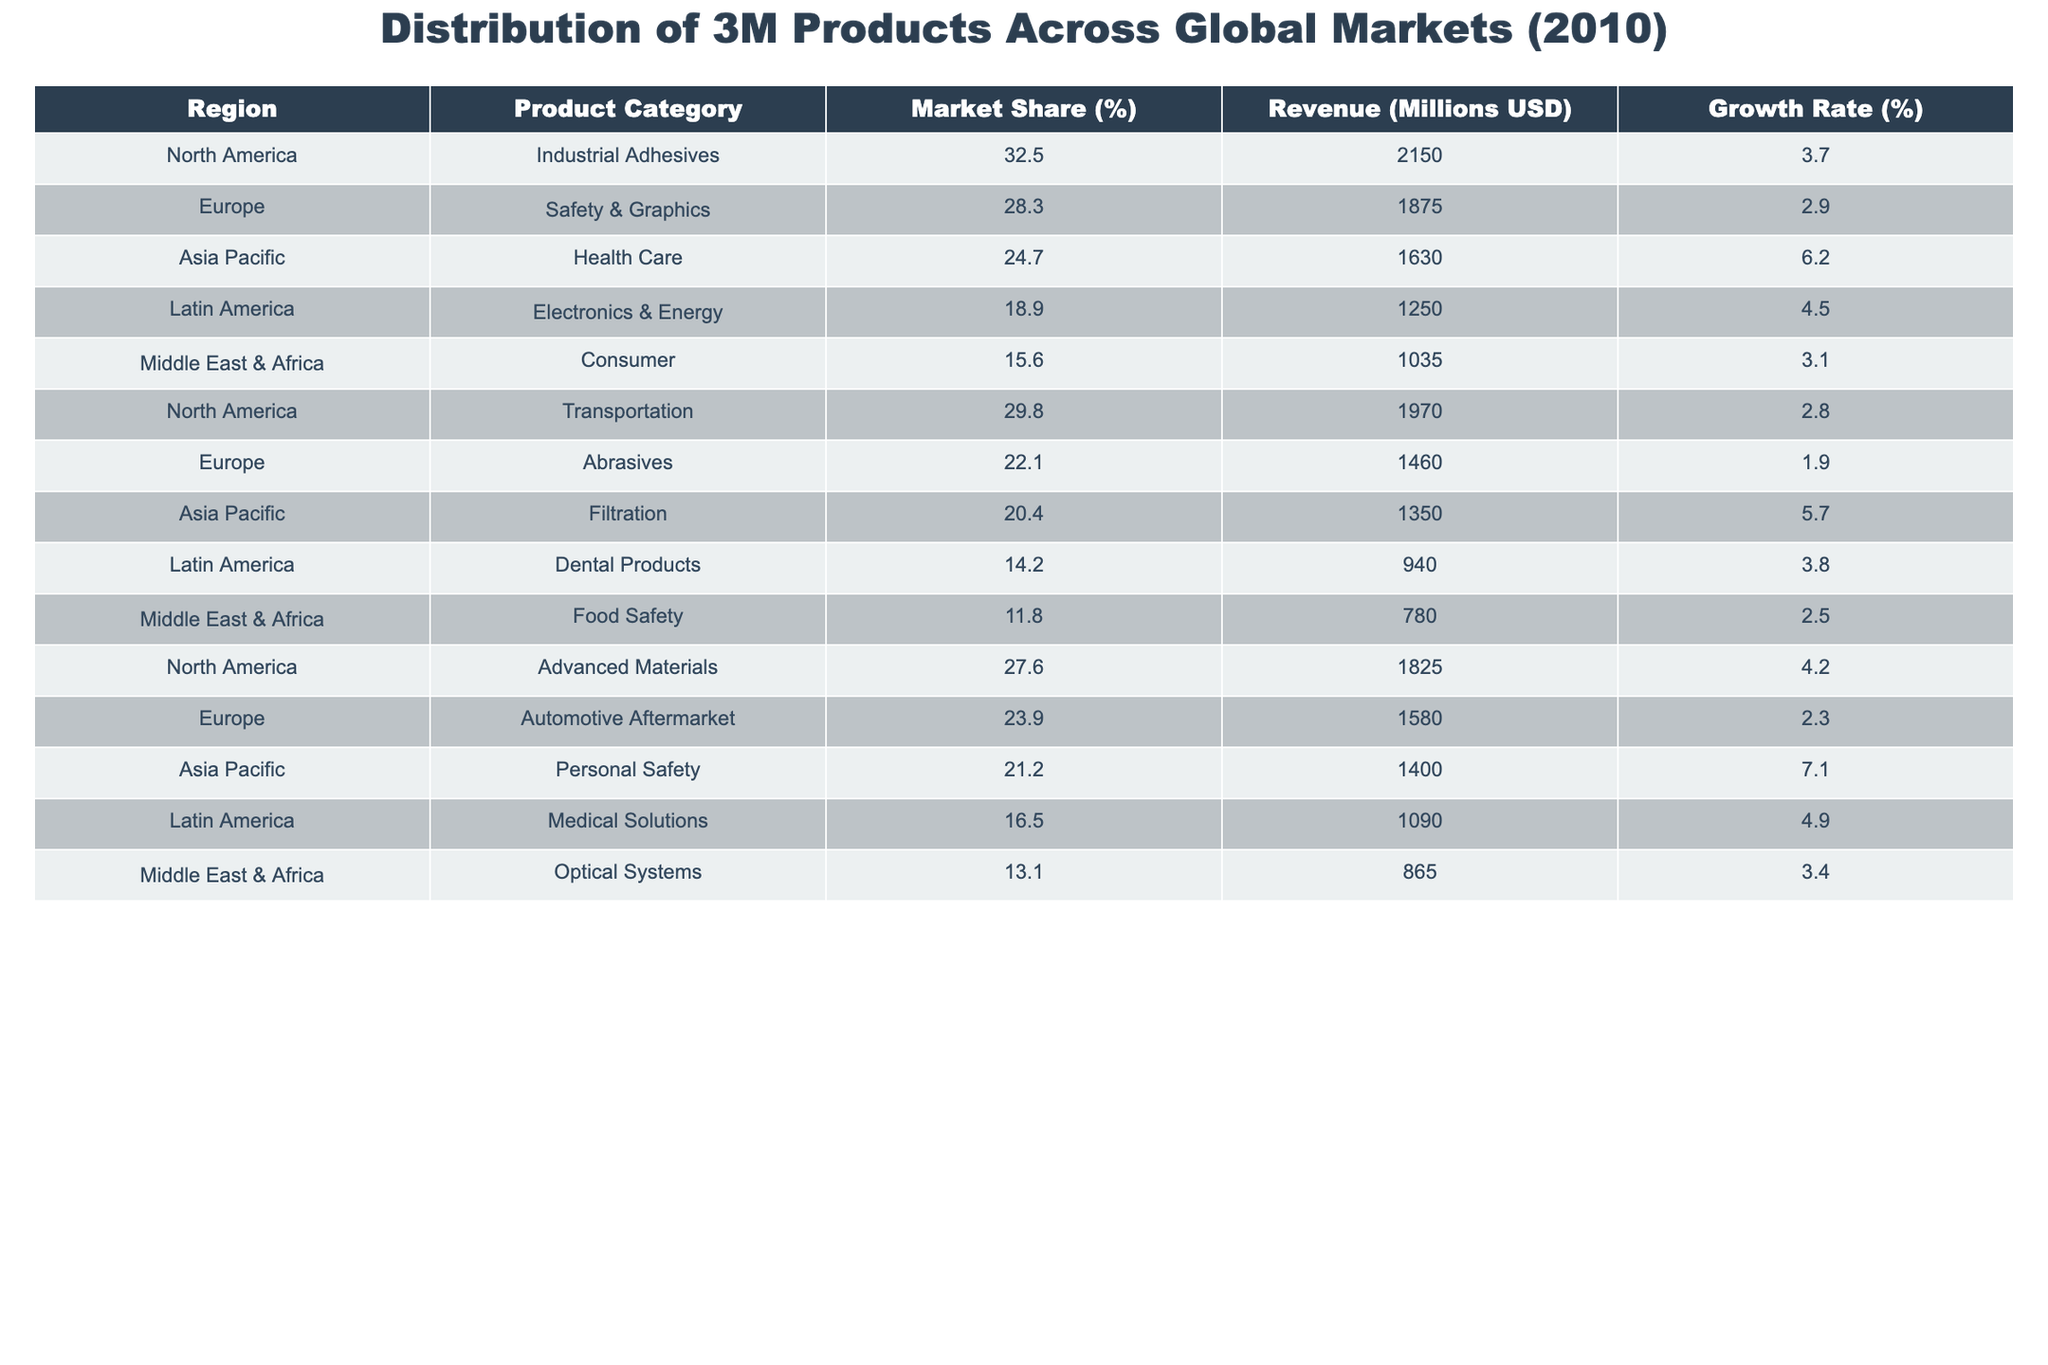What is the market share of Industrial Adhesives in North America? The table shows that Industrial Adhesives has a market share of 32.5% in North America.
Answer: 32.5% Which product category generates the highest revenue in Europe? In the table, Safety & Graphics has the highest revenue of 1875 million USD in Europe.
Answer: Safety & Graphics What is the growth rate of Personal Safety in Asia Pacific? The table lists Personal Safety with a growth rate of 7.1% in the Asia Pacific region.
Answer: 7.1% How does the market share of Consumer products in the Middle East & Africa compare to that of Food Safety? The market share of Consumer is 15.6% while Food Safety is 11.8%, which indicates that Consumer has a higher market share by 3.8%.
Answer: Yes, Consumer has a higher market share What is the total revenue generated by 3M products in Latin America? Adding the revenues of Electronics & Energy (1250 million USD), Dental Products (940 million USD), and Medical Solutions (1090 million USD), the total revenue is 1250 + 940 + 1090 = 3280 million USD.
Answer: 3280 million USD Which region has the lowest growth rate among the listed product categories? The lowest growth rate listed is 1.9% for Abrasives in Europe.
Answer: Abrasives in Europe What is the average market share of the product categories in North America? The market shares in North America are 32.5%, 29.8%, and 27.6%. Summing them gives 32.5 + 29.8 + 27.6 = 89.9; dividing by 3 gives an average of 29.97%.
Answer: 29.97% How many product categories in Asia Pacific have a growth rate above 6%? The table shows two product categories with growth rates above 6%: Health Care (6.2%) and Personal Safety (7.1%).
Answer: 2 What is the difference in market share between the highest and lowest categories in Europe? The highest market share in Europe is 28.3% for Safety & Graphics and the lowest is 22.1% for Abrasives. The difference is 28.3 - 22.1 = 6.2%.
Answer: 6.2% Is the revenue from Advanced Materials in North America greater than that from Automotive Aftermarket in Europe? Advanced Materials generates 1825 million USD in North America, while Automotive Aftermarket generates 1580 million USD in Europe. Therefore, the revenue from Advanced Materials is greater.
Answer: Yes, it is greater 